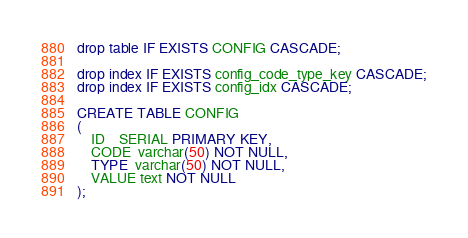Convert code to text. <code><loc_0><loc_0><loc_500><loc_500><_SQL_>drop table IF EXISTS CONFIG CASCADE;

drop index IF EXISTS config_code_type_key CASCADE;
drop index IF EXISTS config_idx CASCADE;

CREATE TABLE CONFIG
(
    ID    SERIAL PRIMARY KEY,
    CODE  varchar(50) NOT NULL,
    TYPE  varchar(50) NOT NULL,
    VALUE text NOT NULL
);


</code> 